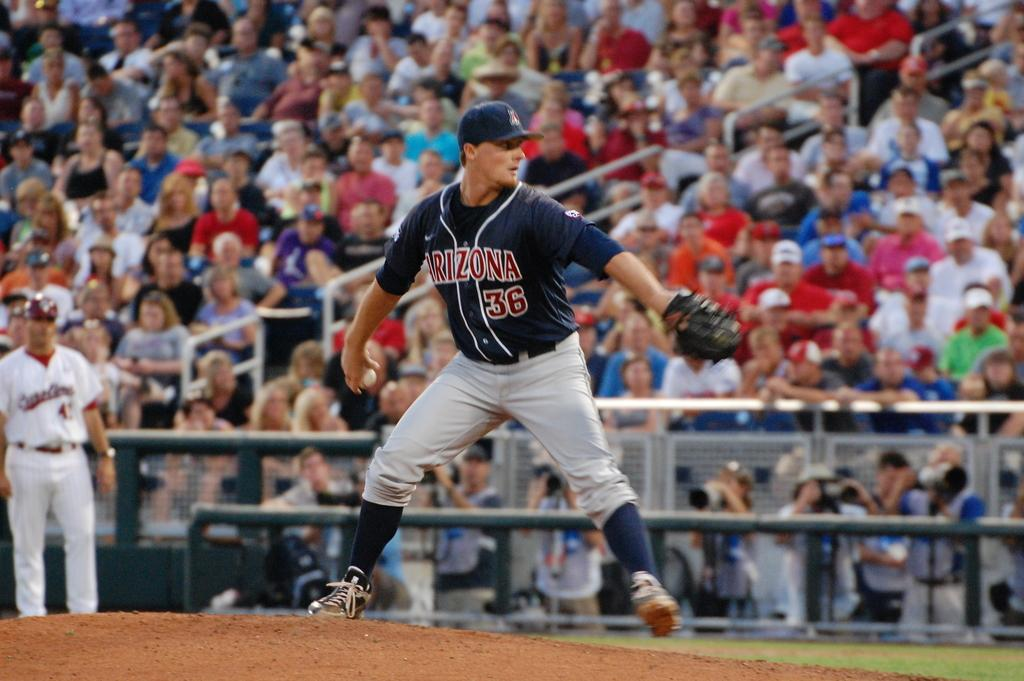Provide a one-sentence caption for the provided image. An Arizona baseball player about to make a pitch in front of a crowd. 